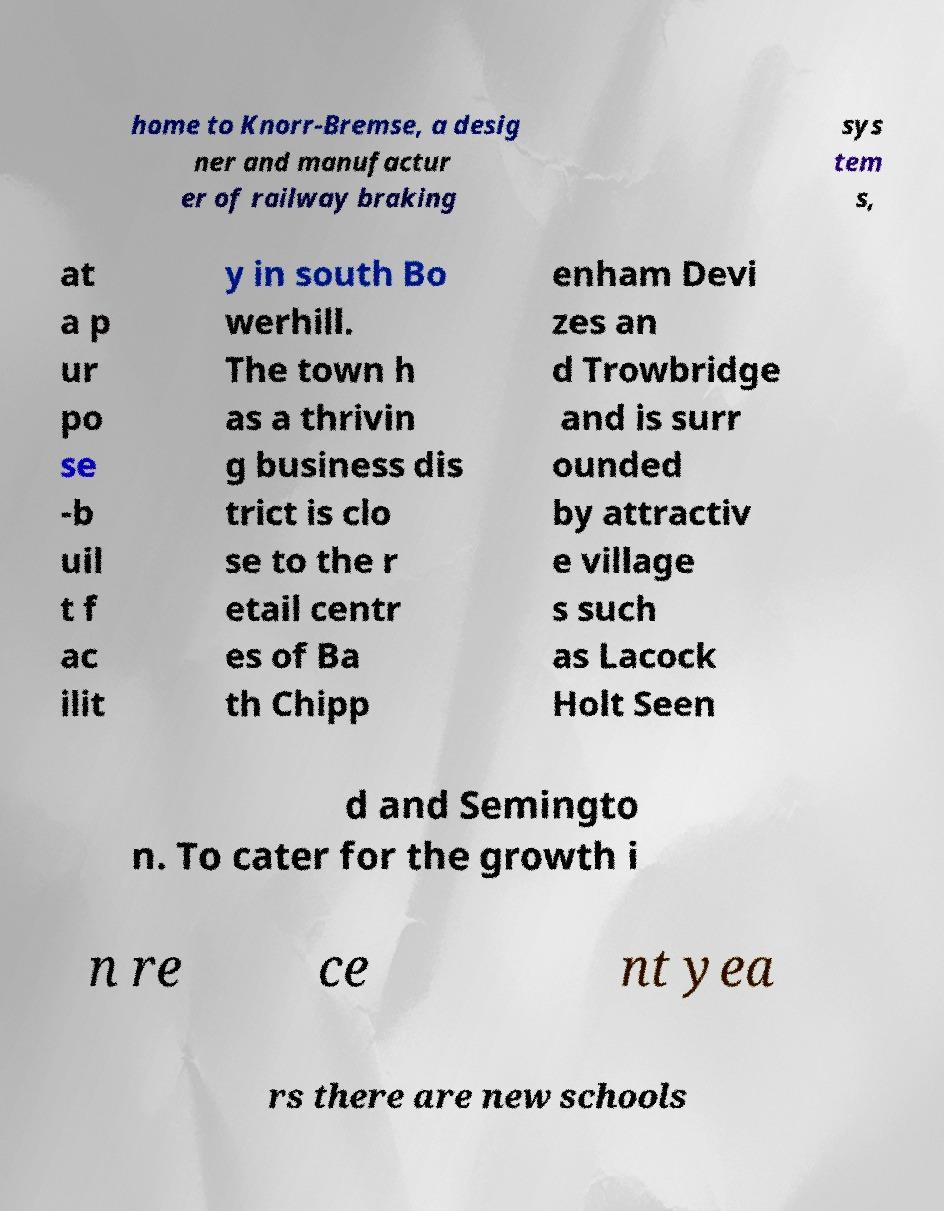I need the written content from this picture converted into text. Can you do that? home to Knorr-Bremse, a desig ner and manufactur er of railway braking sys tem s, at a p ur po se -b uil t f ac ilit y in south Bo werhill. The town h as a thrivin g business dis trict is clo se to the r etail centr es of Ba th Chipp enham Devi zes an d Trowbridge and is surr ounded by attractiv e village s such as Lacock Holt Seen d and Semingto n. To cater for the growth i n re ce nt yea rs there are new schools 